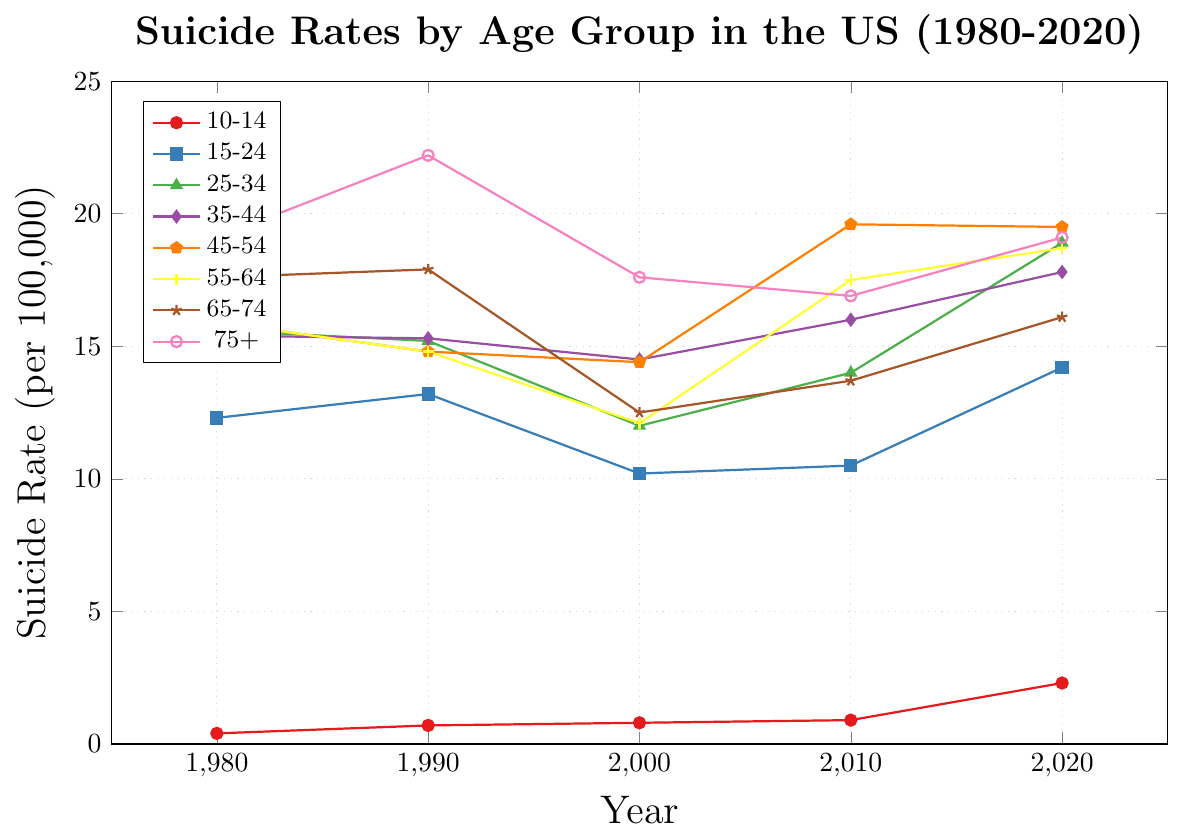What is the trend in suicide rates for the 10-14 age group from 1980 to 2020? The suicide rate for the 10-14 age group starts at 0.4 in 1980, increasing to 0.7 in 1990, then to 0.8 in 2000, then 0.9 in 2010, and finally to 2.3 in 2020. This shows a steady increase over the four decades.
Answer: Increasing Which age group had the highest suicide rate in 2020? The suicide rates in 2020 are: 10-14 (2.3), 15-24 (14.2), 25-34 (18.9), 35-44 (17.8), 45-54 (19.5), 55-64 (18.7), 65-74 (16.1), and 75+ (19.1). The age group 25-34 had the highest rate at 18.9 per 100,000.
Answer: 25-34 How does the suicide rate in the 75+ age group change from 1990 to 2020? The suicide rates for the 75+ age group in 1990, 2000, 2010, and 2020 are 22.2, 17.6, 16.9, and 19.1 respectively. The rate first decreased from 22.2 to 17.6 between 1990 and 2000, then slightly decreased to 16.9 in 2010, and finally increased to 19.1 in 2020.
Answer: Decrease overall, then increase Which age group had the most significant increase in suicide rate from 1980 to 2020? To find the age group with the most significant increase, we calculate the differences: 10-14 (2.3 - 0.4 = +1.9), 15-24 (14.2 - 12.3 = +1.9), 25-34 (18.9 - 15.6 = +3.3), 35-44 (17.8 - 15.4 = +2.4), 45-54 (19.5 - 15.9 = +3.6), 55-64 (18.7 - 15.9 = +2.8), 65-74 (16.1 - 17.6 = -1.5), and 75+ (19.1 - 19.1 = 0). The age group 45-54 had the highest increase in suicide rate, which is +3.6.
Answer: 45-54 Compare the change in suicide rates for the age groups 35-44 and 45-54 between 2000 and 2010. Which group had a larger increase? The suicide rate for the 35-44 age group increased from 14.5 in 2000 to 16.0 in 2010, an increase of 1.5. The suicide rate for the 45-54 age group increased from 14.4 in 2000 to 19.6 in 2010, an increase of 5.2. Therefore, the 45-54 age group had a larger increase.
Answer: 45-54 Which age group has the most variability in suicide rates over the years observed? Variability can be judged by the range, calculated as the difference between the maximum and minimum values for each age group: 10-14 (2.3 - 0.4 = 1.9), 15-24 (14.2 - 10.2 = 4.0), 25-34 (18.9 - 12 = 6.9), 35-44 (17.8 - 14.5 = 3.3), 45-54 (19.6 - 14.4 = 5.2), 55-64 (18.7 - 12.1 = 6.6), 65-74 (17.9 - 12.5 = 5.4), and 75+ (22.2 - 16.9 = 5.3). The 25-34 age group shows the most variability with a range of 6.9.
Answer: 25-34 Which age group showed a decrease in suicide rates between 1980 and 2000? Observing the rates: 10-14 (0.4 to 0.8), 15-24 (12.3 to 10.2), 25-34 (15.6 to 12.0), 35-44 (15.4 to 14.5), 45-54 (15.9 to 14.4), 55-64 (15.9 to 12.1), 65-74 (17.6 to 12.5), and 75+ (19.1 to 17.6). The age groups 15-24, 25-34, 35-44, 45-54, 55-64, 65-74, and 75+ all showed a decrease.
Answer: 15-24, 25-34, 35-44, 45-54, 55-64, 65-74, 75+ What is the average suicide rate for the age group 55-64 over the observed time period? The rates for 55-64 are 15.9, 14.8, 12.1, 17.5, and 18.7. The sum is 78. The number of values is 5. Therefore, the average rate is 78 / 5 = 15.6.
Answer: 15.6 Compare the suicide rates of the age group 35-44 and 45-54 in 2020. Which age group had a higher rate? The suicide rates in 2020 are 17.8 for 35-44 and 19.5 for 45-54. The 45-54 age group had a higher rate.
Answer: 45-54 